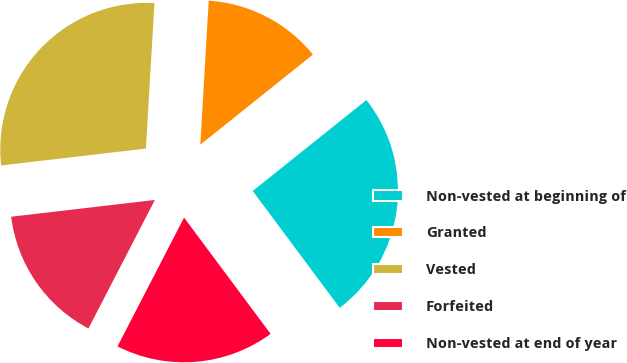Convert chart. <chart><loc_0><loc_0><loc_500><loc_500><pie_chart><fcel>Non-vested at beginning of<fcel>Granted<fcel>Vested<fcel>Forfeited<fcel>Non-vested at end of year<nl><fcel>25.56%<fcel>13.33%<fcel>27.78%<fcel>15.56%<fcel>17.78%<nl></chart> 